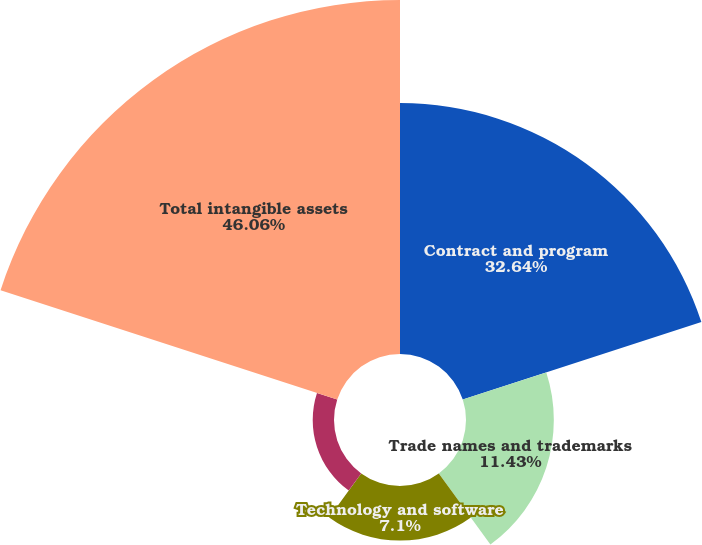Convert chart. <chart><loc_0><loc_0><loc_500><loc_500><pie_chart><fcel>Contract and program<fcel>Trade names and trademarks<fcel>Technology and software<fcel>Other intangible assets<fcel>Total intangible assets<nl><fcel>32.65%<fcel>11.43%<fcel>7.1%<fcel>2.77%<fcel>46.07%<nl></chart> 